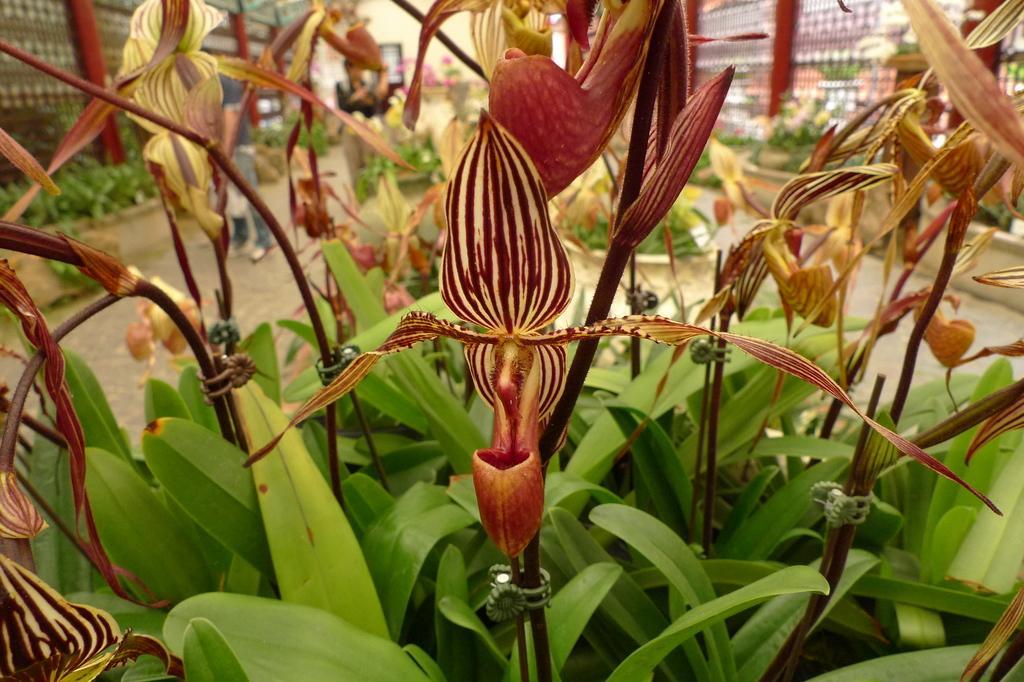Could you give a brief overview of what you see in this image? In this picture, we see the plants which have flowers. These flowers are in yellow and brown color. Behind that, we see two people are standing. On the left side, we see a wall and the shrubs. There are plants and the buildings in the background. 